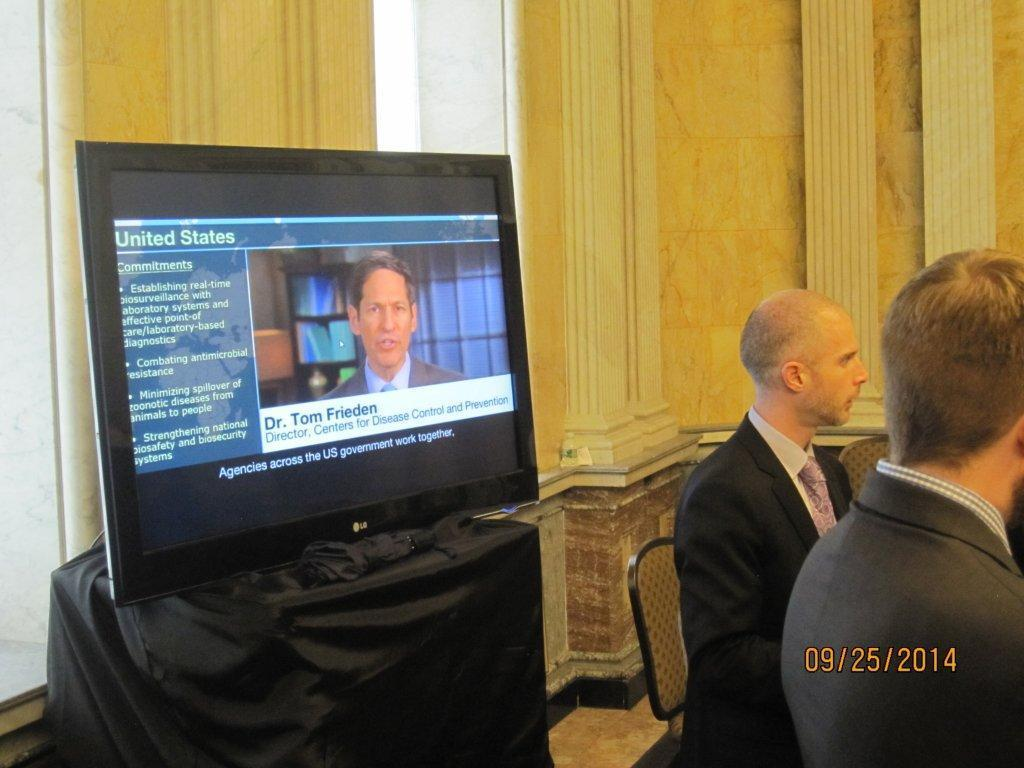<image>
Give a short and clear explanation of the subsequent image. People sitting at a table while a TV displays Dr. Tom Frieden 